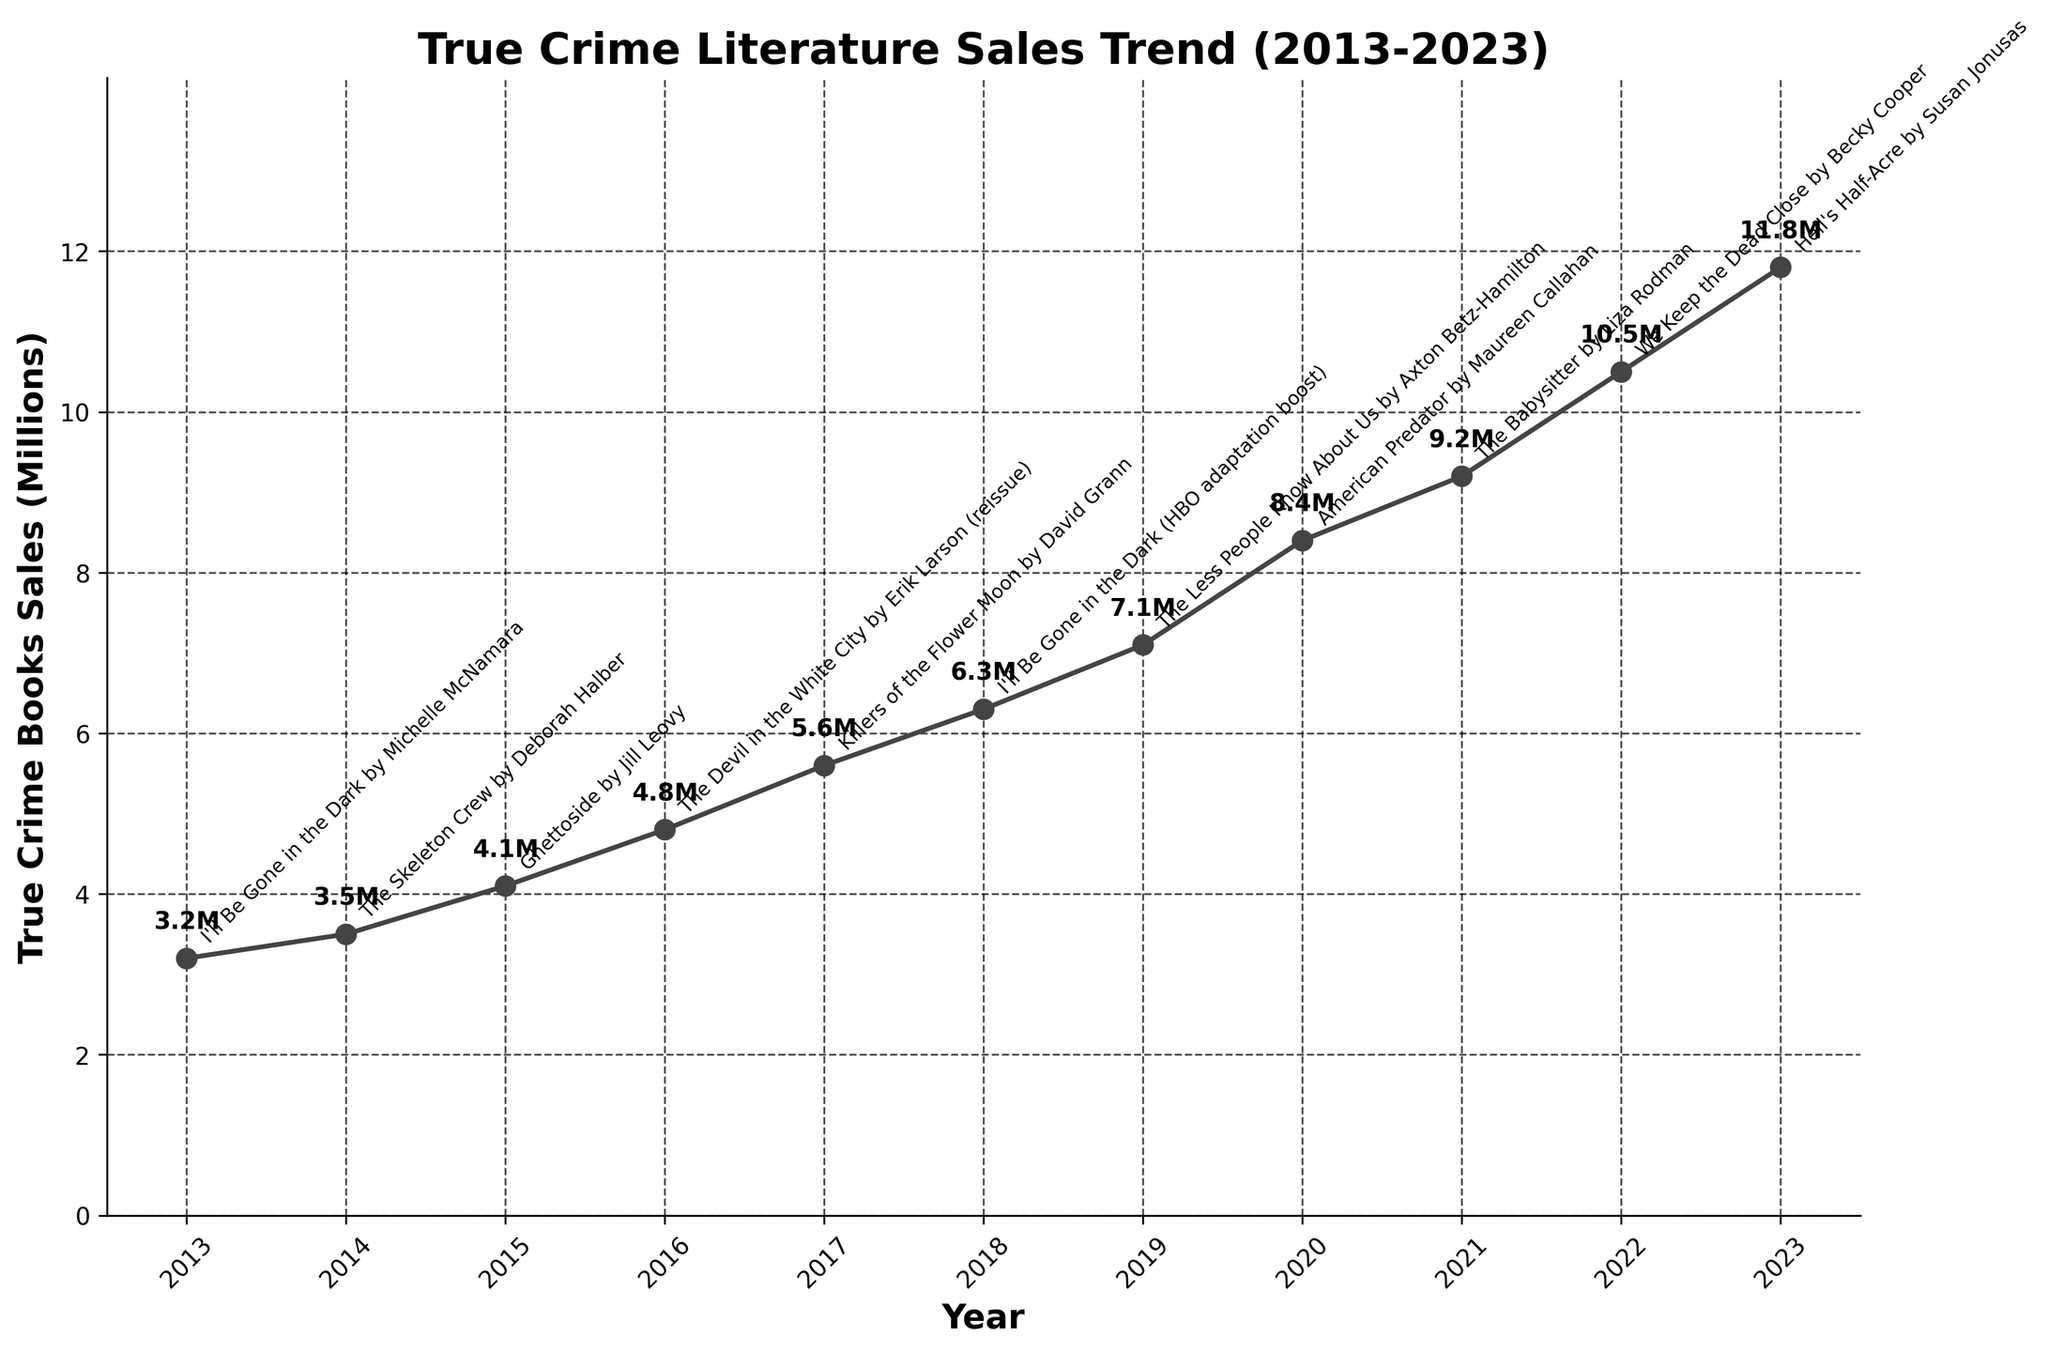What is the overall trend in true crime book sales from 2013 to 2023? The overall trend in true crime book sales from 2013 to 2023 shows a consistent increase each year. This indicates a growing interest in true crime literature over the past decade.
Answer: Increasing Which year had the largest increase in sales compared to the previous year? To determine the largest increase, compare the year-to-year differences in sales. The largest increase in sales occurred from 2019 (7.1 million) to 2020 (8.4 million), which is an increase of 1.3 million.
Answer: 2020 What notable release coincided with the year that had the highest sales? The highest sales occurred in 2023 with 11.8 million sales. The notable release in that year was "Hell's Half-Acre by Susan Jonusas."
Answer: Hell's Half-Acre by Susan Jonusas Which notable release had a reissue, and in which year did it happen? The notable release with a reissue is "The Devil in the White City by Erik Larson" which happened in 2016.
Answer: The Devil in the White City by Erik Larson, 2016 How many total millions of true crime books were sold from 2019 to 2021? Sum the sales for the years 2019, 2020, and 2021: 7.1 + 8.4 + 9.2 = 24.7 million.
Answer: 24.7 million Between which two consecutive years was the increase in sales the smallest? Calculate the increase in sales between consecutive years and find the smallest one: 2013-2014: 0.3, 2014-2015: 0.6, 2015-2016: 0.7, 2016-2017: 0.8, 2017-2018: 0.7, 2018-2019: 0.8, 2019-2020: 1.3, 2020-2021: 0.8, 2021-2022: 1.3, 2022-2023: 1.3. The smallest increase is from 2013 to 2014, which is 0.3 million.
Answer: 2013-2014 By how much did sales increase from 2013 to 2018? Subtract the sales in 2013 from the sales in 2018: 6.3 - 3.2 = 3.1 million.
Answer: 3.1 million Which years had sales of at least 10 million? Identify the years where sales are 10 million or more: Only 2022 and 2023 had sales of at least 10 million, with figures of 10.5 million and 11.8 million, respectively.
Answer: 2022, 2023 What was the average annual increase in sales from 2016 to 2019? Calculate the increases between each year and then find the average: (5.6 - 4.8) + (6.3 - 5.6) + (7.1 - 6.3) = 0.8 + 0.7 + 0.8 = 2.3. Divide by the number of intervals (3): 2.3 / 3 = approximately 0.77 million per year.
Answer: 0.77 million per year What is the biggest contributor to the sales increase in 2018? The notable release for 2018 was "I'll Be Gone in the Dark (HBO adaptation boost)." The HBO adaptation likely contributed significantly to the sales increase due to increased exposure and interest.
Answer: I'll Be Gone in the Dark (HBO adaptation boost) 